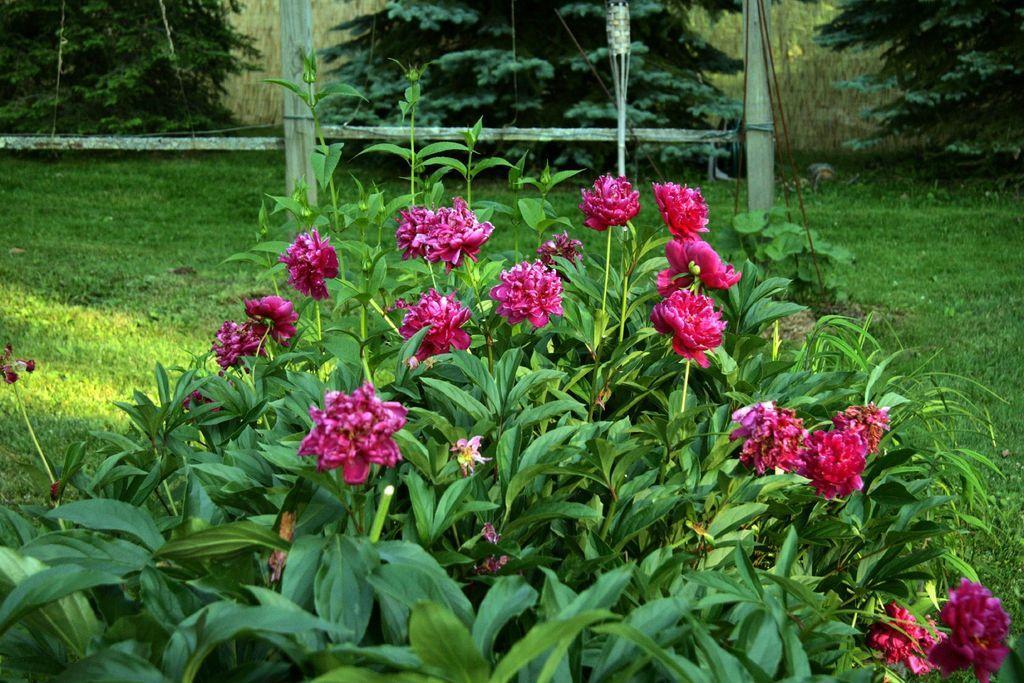In one or two sentences, can you explain what this image depicts? Here we can see plants, flowers, and grass. In the background there are trees. 